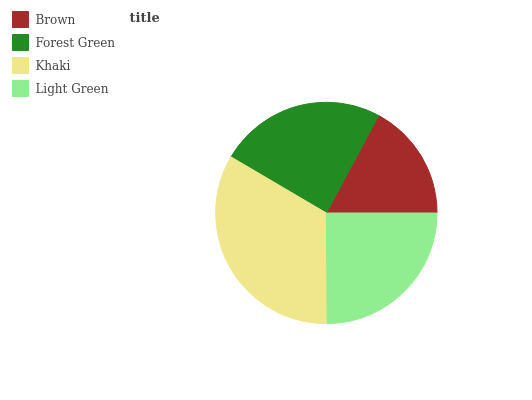Is Brown the minimum?
Answer yes or no. Yes. Is Khaki the maximum?
Answer yes or no. Yes. Is Forest Green the minimum?
Answer yes or no. No. Is Forest Green the maximum?
Answer yes or no. No. Is Forest Green greater than Brown?
Answer yes or no. Yes. Is Brown less than Forest Green?
Answer yes or no. Yes. Is Brown greater than Forest Green?
Answer yes or no. No. Is Forest Green less than Brown?
Answer yes or no. No. Is Light Green the high median?
Answer yes or no. Yes. Is Forest Green the low median?
Answer yes or no. Yes. Is Forest Green the high median?
Answer yes or no. No. Is Khaki the low median?
Answer yes or no. No. 